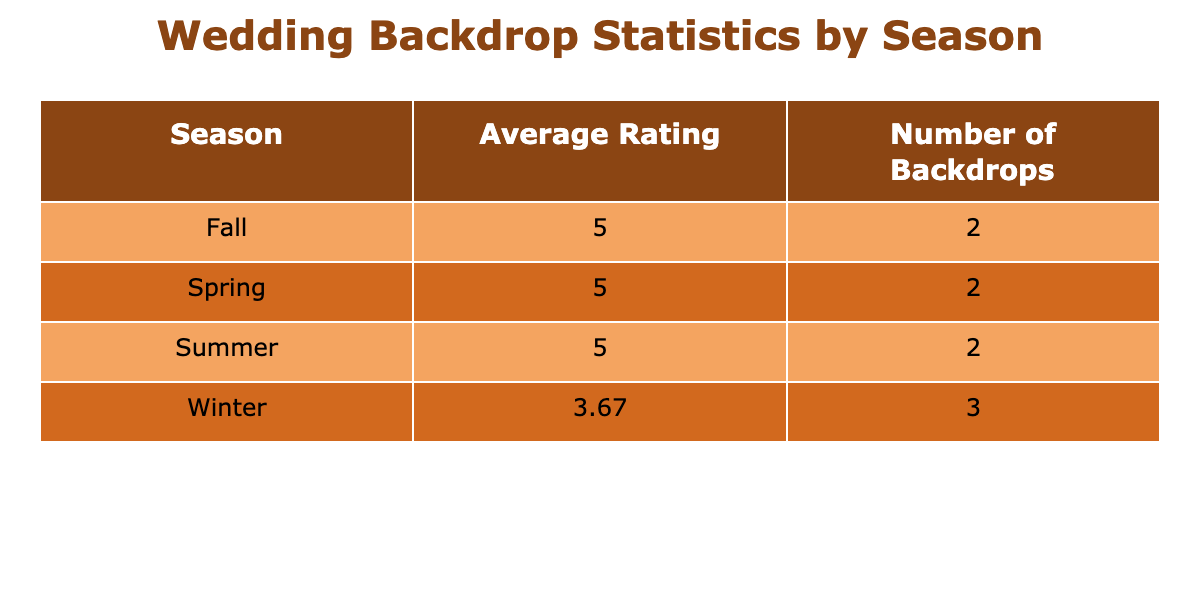What is the average rating for the winter season? To find the average rating for winter, we look at the ratings given in the winter: 4, 5, and 2. We sum these ratings: 4 + 5 + 2 = 11. There are 3 ratings, so to find the average, we divide the total by 3: 11 / 3 = 3.67, rounded to two decimal places gives us 3.67.
Answer: 3.67 How many backdrops were provided in total during the fall season? The fall season had two entries in the table, which means there were 2 backdrops provided in total during this season.
Answer: 2 Which season had the highest average rating? By comparing the average ratings calculated for each season: Spring (5), Summer (5), Fall (5), and Winter (3.67). The maximum value among these averages is 5. Thus, Spring, Summer, and Fall all share the highest average rating.
Answer: Spring, Summer, Fall Is there a backdrop style that received a rating of 2? Upon examining the data, we can see that the Minimalist Arch is the only one that received a rating of 2. This confirms that there is indeed a backdrop style with that rating.
Answer: Yes What is the total number of backdrops across all seasons? We can count the individual entries in each season: Spring (2), Summer (2), Fall (2), and Winter (3). Adding these together gives us: 2 + 2 + 2 + 3 = 9. Thus, there is a total of 9 backdrops across all seasons.
Answer: 9 How does the average rating of fall backdrops compare to that of winter backdrops? The average rating for fall is 5, while for winter it is 3.67. We can see that the fall average is higher than the winter average. The numerical difference is: 5 - 3.67 = 1.33. Hence, fall's average rating is superior by 1.33 points.
Answer: Fall is higher by 1.33 Which season had the least number of backdrops and how many? Looking at the number of backdrops, we see that Spring, Summer, and Fall each had 2, while Winter had 3. Therefore, the seasons with the least number of backdrops are Spring, Summer, and Fall, each with 2 backdrops.
Answer: Spring, Summer, Fall - 2 backdrops What is the overall total rating score of all backdrops? To find the overall total rating score, we sum the ratings: 5 + 5 + 5 + 5 + 5 + 4 + 5 + 2 = 36. This provides us with the total score of 36 across all backdrops.
Answer: 36 